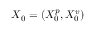<formula> <loc_0><loc_0><loc_500><loc_500>X _ { 0 } = ( X _ { 0 } ^ { p } , X _ { 0 } ^ { v } )</formula> 